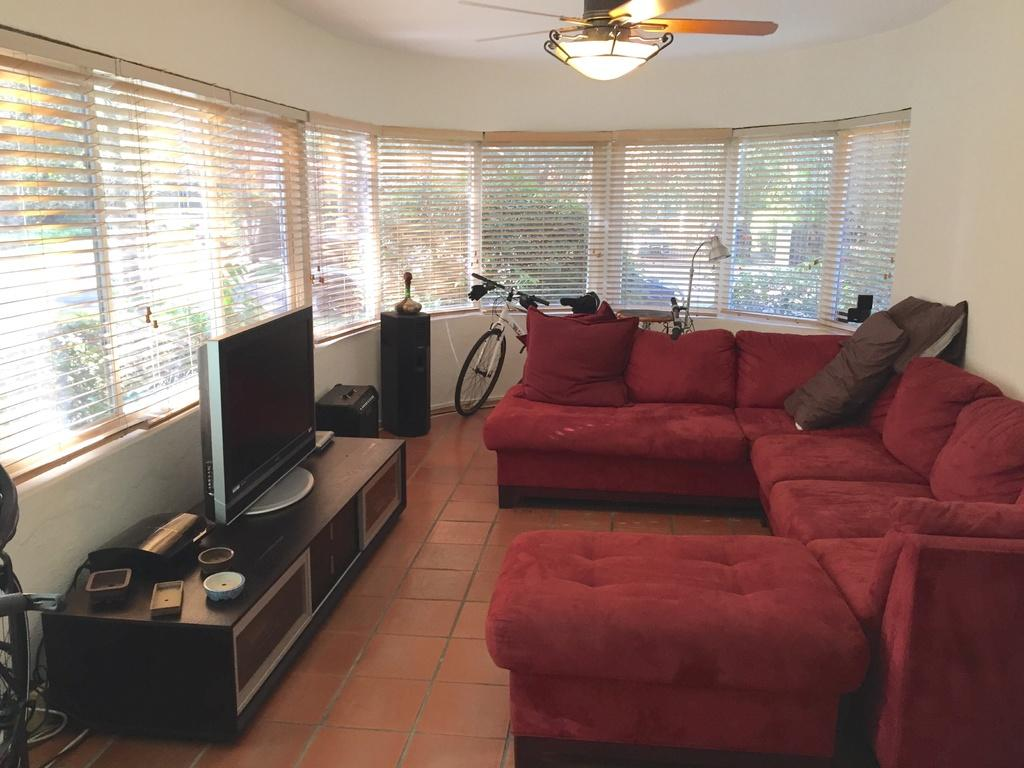What type of space is shown in the image? The image depicts the interior of a room. What electronic device can be seen in the room? There is a television in the room. What type of furniture is in the room? There is a sofa in the room. What other objects are present in the room? There is a bicycle and a fan in the room. What is the source of light in the room? There is a light in the room. What can be seen in the background of the image? There are trees visible in the background of the image. What type of whip is being used to play with the bicycle in the image? There is no whip or playing with the bicycle present in the image. How does the fan grip the handlebars of the bicycle in the image? There is no fan interacting with the bicycle in the image; the fan is a separate object. 